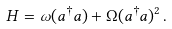Convert formula to latex. <formula><loc_0><loc_0><loc_500><loc_500>H = \omega ( a ^ { \dagger } a ) + \Omega ( a ^ { \dagger } a ) ^ { 2 } \, .</formula> 